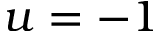<formula> <loc_0><loc_0><loc_500><loc_500>u = - 1</formula> 